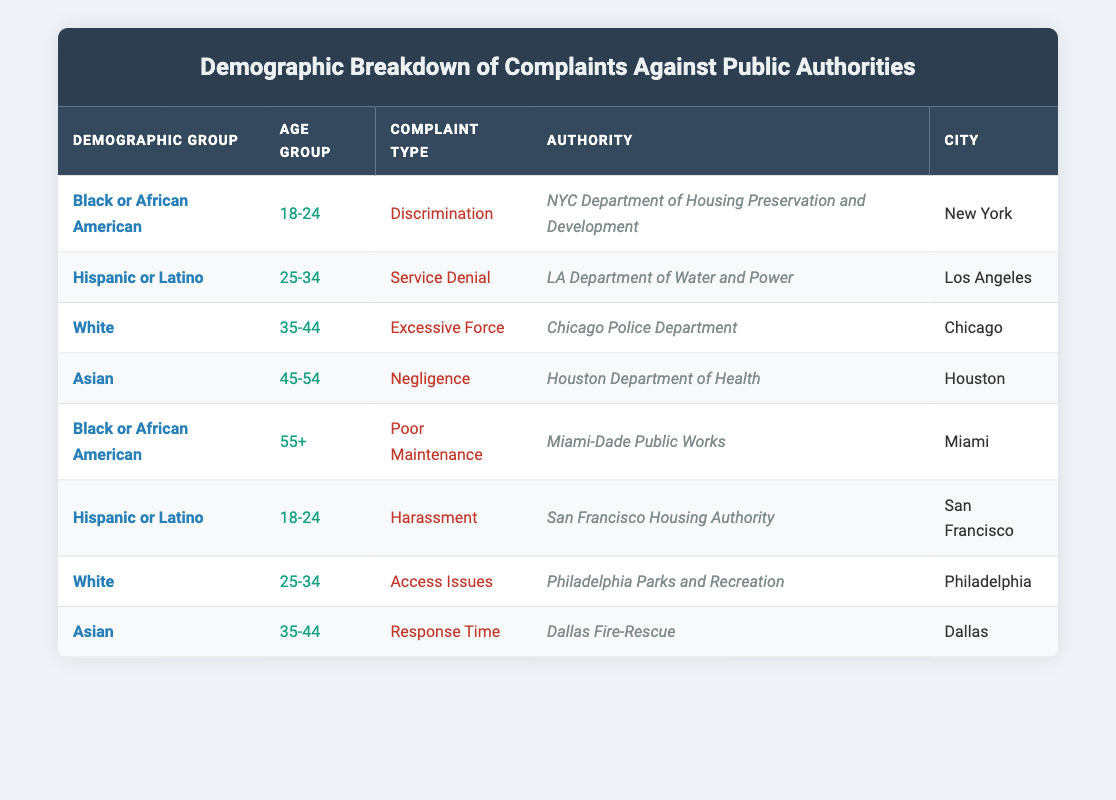What is the demographic group that submitted a complaint about Discrimination? Looking at the table, the complaint type "Discrimination" corresponds to the demographic group "Black or African American" under the age group "18-24" in New York.
Answer: Black or African American How many complaints are made by the Asian demographic group? By counting the rows where the demographic group is "Asian," we find there are 2 complaints—one for "Negligence" and another for "Response Time."
Answer: 2 Is there a complaint type related to Excessive Force? Yes, the table indicates that there is a complaint in the complaint type "Excessive Force," submitted by a White individual in the age group "35-44."
Answer: Yes Which authority received a complaint about Poor Maintenance? The table shows that the "Miami-Dade Public Works" authority received the complaint categorized as "Poor Maintenance" from a "Black or African American" demographic in the age group "55+."
Answer: Miami-Dade Public Works What is the average age group of complaints filed by Hispanic or Latino individuals? The complaints filed by Hispanic or Latino individuals are in the age groups "18-24" and "25-34." Averages for age groups can be complex, but in this case, we can consider these age ranges. Therefore, we can say there are two relevant age groups without specific numerical averaging necessary.
Answer: 2 age groups: 18-24 and 25-34 Are there any complaints related to Harassment? Yes, the table includes a complaint categorized as "Harassment" submitted by a Hispanic or Latino individual in the 18-24 age group.
Answer: Yes What types of complaints are present for individuals aged 25-34? Review the entries for the age group "25-34," which include "Service Denial" by a Hispanic or Latino individual, and "Access Issues" by a White individual, making a total of two different types of complaints.
Answer: 2 types: Service Denial, Access Issues Which city has the most varied demographic group for complaints? By analyzing the table, we see complaints involve Black, Hispanic, White, and Asian demographic groups across different cities. Each city displays at least one complaint with no clear city having more diverse representation than others. It appears to be an evenly distributed breakdown without emphasizing any city over others in terms of varied groups.
Answer: None specifically highlighted How many complaint types are recorded for the age group 35-44? In the table, there are two complaints for individuals in the age group "35-44"—one for "Excessive Force" and another for "Response Time," indicating a total of 2 different complaint types for this age group.
Answer: 2 types Which authority received the most complaints from the demographic group 'White'? Referring to the table, the "Chicago Police Department" and "Philadelphia Parks and Recreation" both have complaints submitted by White individuals. However, since there are only 2 complaints total from this demographic, no one authority dominates in complaints.
Answer: 2 authorities (equal complaints) 